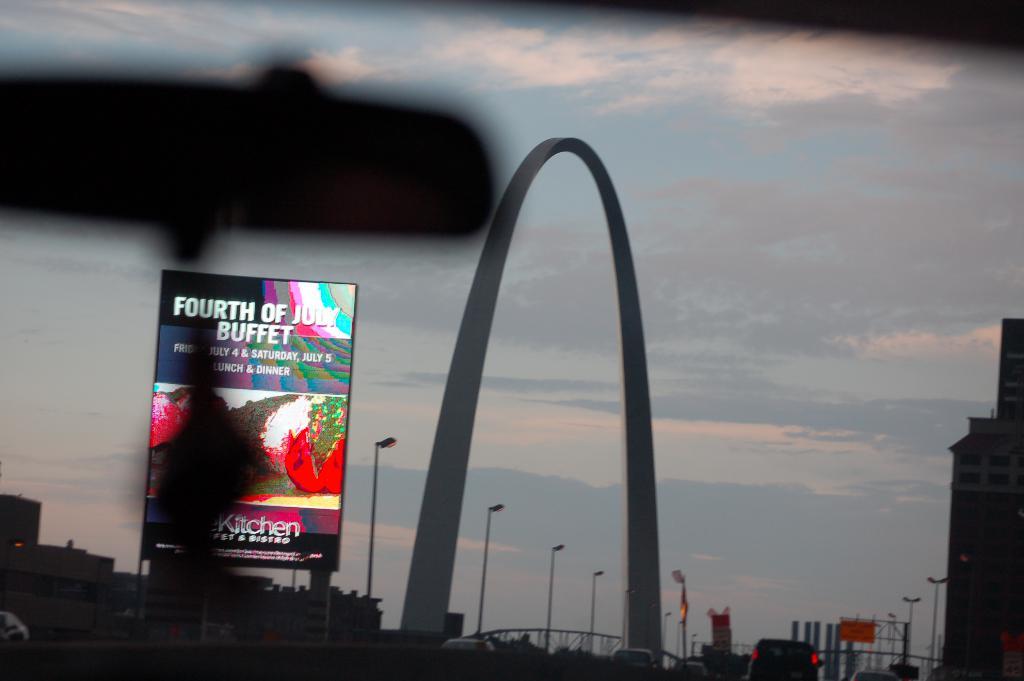Where is the buffet at?
Your answer should be compact. Fourth of july. 